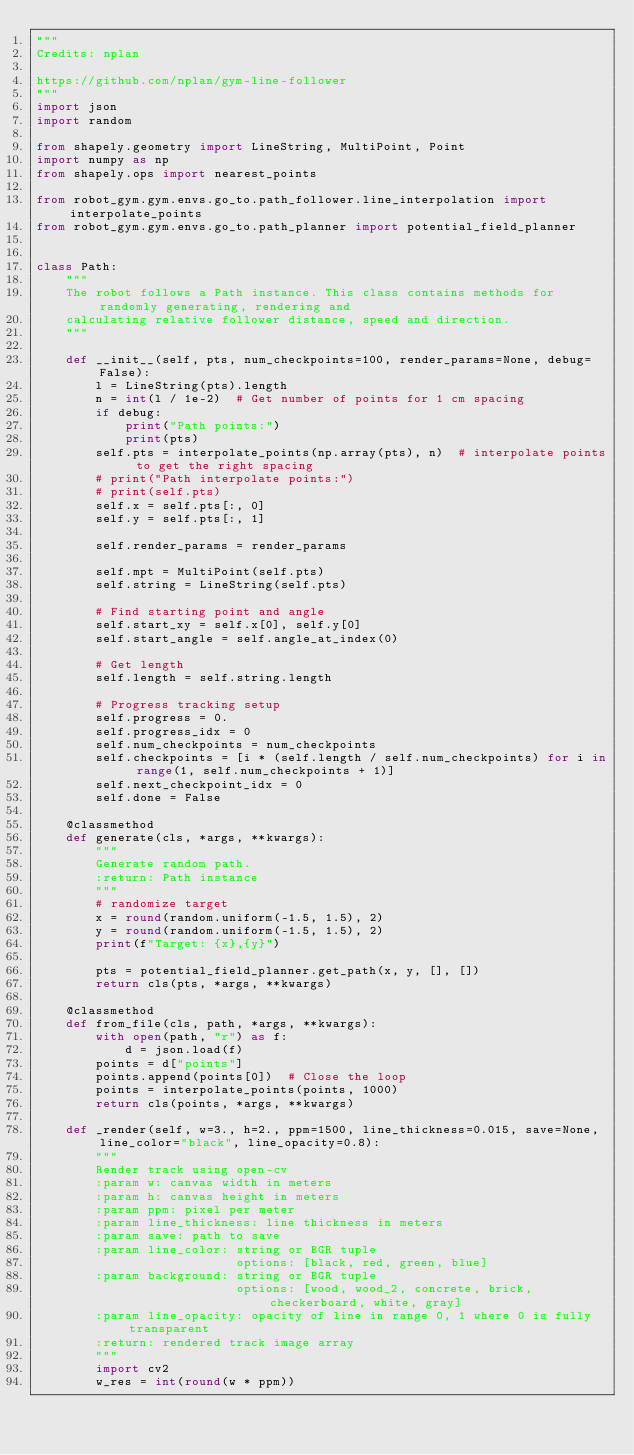<code> <loc_0><loc_0><loc_500><loc_500><_Python_>"""
Credits: nplan

https://github.com/nplan/gym-line-follower
"""
import json
import random

from shapely.geometry import LineString, MultiPoint, Point
import numpy as np
from shapely.ops import nearest_points

from robot_gym.gym.envs.go_to.path_follower.line_interpolation import interpolate_points
from robot_gym.gym.envs.go_to.path_planner import potential_field_planner


class Path:
    """
    The robot follows a Path instance. This class contains methods for randomly generating, rendering and
    calculating relative follower distance, speed and direction.
    """

    def __init__(self, pts, num_checkpoints=100, render_params=None, debug=False):
        l = LineString(pts).length
        n = int(l / 1e-2)  # Get number of points for 1 cm spacing
        if debug:
            print("Path points:")
            print(pts)
        self.pts = interpolate_points(np.array(pts), n)  # interpolate points to get the right spacing
        # print("Path interpolate points:")
        # print(self.pts)
        self.x = self.pts[:, 0]
        self.y = self.pts[:, 1]

        self.render_params = render_params

        self.mpt = MultiPoint(self.pts)
        self.string = LineString(self.pts)

        # Find starting point and angle
        self.start_xy = self.x[0], self.y[0]
        self.start_angle = self.angle_at_index(0)

        # Get length
        self.length = self.string.length

        # Progress tracking setup
        self.progress = 0.
        self.progress_idx = 0
        self.num_checkpoints = num_checkpoints
        self.checkpoints = [i * (self.length / self.num_checkpoints) for i in range(1, self.num_checkpoints + 1)]
        self.next_checkpoint_idx = 0
        self.done = False

    @classmethod
    def generate(cls, *args, **kwargs):
        """
        Generate random path.
        :return: Path instance
        """
        # randomize target
        x = round(random.uniform(-1.5, 1.5), 2)
        y = round(random.uniform(-1.5, 1.5), 2)
        print(f"Target: {x},{y}")

        pts = potential_field_planner.get_path(x, y, [], [])
        return cls(pts, *args, **kwargs)

    @classmethod
    def from_file(cls, path, *args, **kwargs):
        with open(path, "r") as f:
            d = json.load(f)
        points = d["points"]
        points.append(points[0])  # Close the loop
        points = interpolate_points(points, 1000)
        return cls(points, *args, **kwargs)

    def _render(self, w=3., h=2., ppm=1500, line_thickness=0.015, save=None, line_color="black", line_opacity=0.8):
        """
        Render track using open-cv
        :param w: canvas width in meters
        :param h: canvas height in meters
        :param ppm: pixel per meter
        :param line_thickness: line thickness in meters
        :param save: path to save
        :param line_color: string or BGR tuple
                           options: [black, red, green, blue]
        :param background: string or BGR tuple
                           options: [wood, wood_2, concrete, brick, checkerboard, white, gray]
        :param line_opacity: opacity of line in range 0, 1 where 0 is fully transparent
        :return: rendered track image array
        """
        import cv2
        w_res = int(round(w * ppm))</code> 